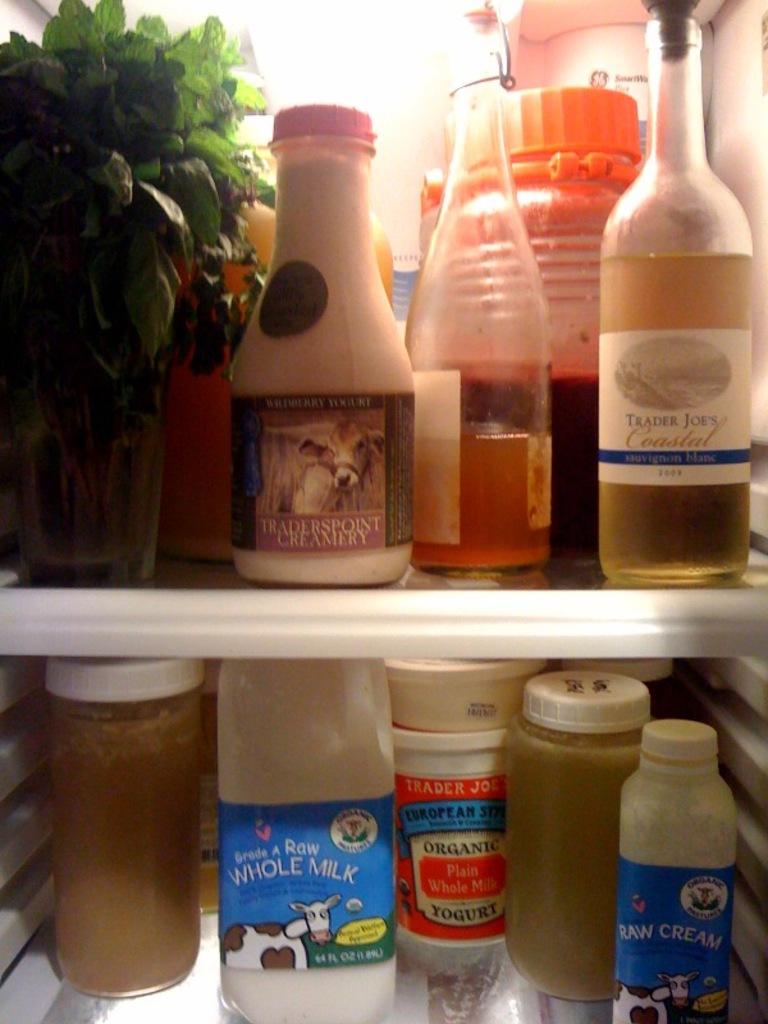What are the two prominent words on the milk?
Your response must be concise. Whole milk. 